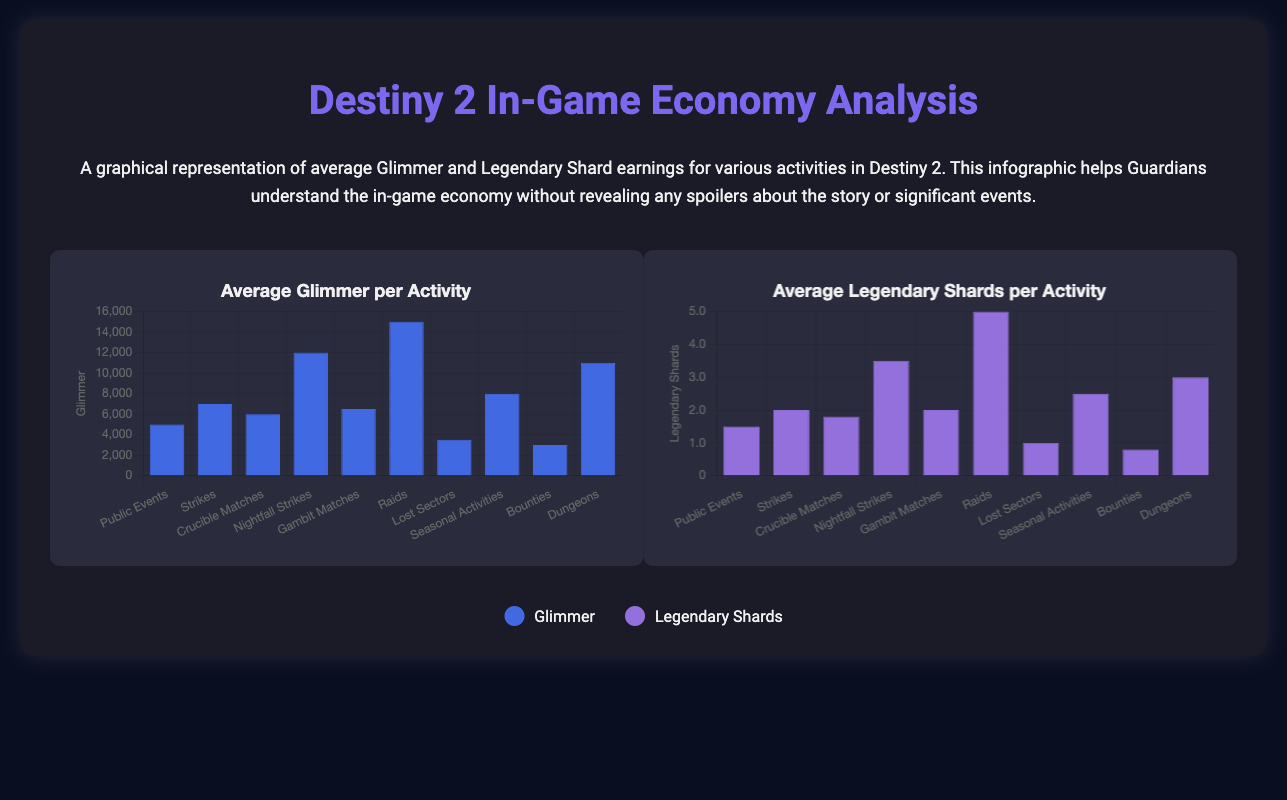What is the average Glimmer earned from Raids? The document shows that the average Glimmer earned from Raids is 15000.
Answer: 15000 How many Legendary Shards can you earn from Nightfall Strikes on average? The infographic states that the average Legendary Shards earned from Nightfall Strikes is 3.5.
Answer: 3.5 Which activity yields the least amount of Glimmer? According to the data, Bounties provide the least amount of Glimmer, which is 3000.
Answer: Bounties What is the average Glimmer earned from Lost Sectors? The average Glimmer for Lost Sectors is 3500, as indicated in the chart.
Answer: 3500 Which activity yields the most Legendary Shards? The infographic indicates that Raids yield the highest amount of Legendary Shards at 5.
Answer: 5 What is the average earnings of Glimmer from Seasonal Activities? The average Glimmer from Seasonal Activities is shown to be 8000.
Answer: 8000 What can be inferred about the Glimmer earnings from Strikes compared to Crucible Matches? Strikes yield more Glimmer (7000) than Crucible Matches (6000), indicating that Strikes are more rewarding in terms of Glimmer.
Answer: Strikes yield more Glimmer Which activity has a higher average of Legendary Shards: Gambit Matches or Crucible Matches? The document states that Gambit Matches provide 2 Legendary Shards while Crucible Matches provide 1.8, making Gambit Matches more rewarding.
Answer: Gambit Matches 